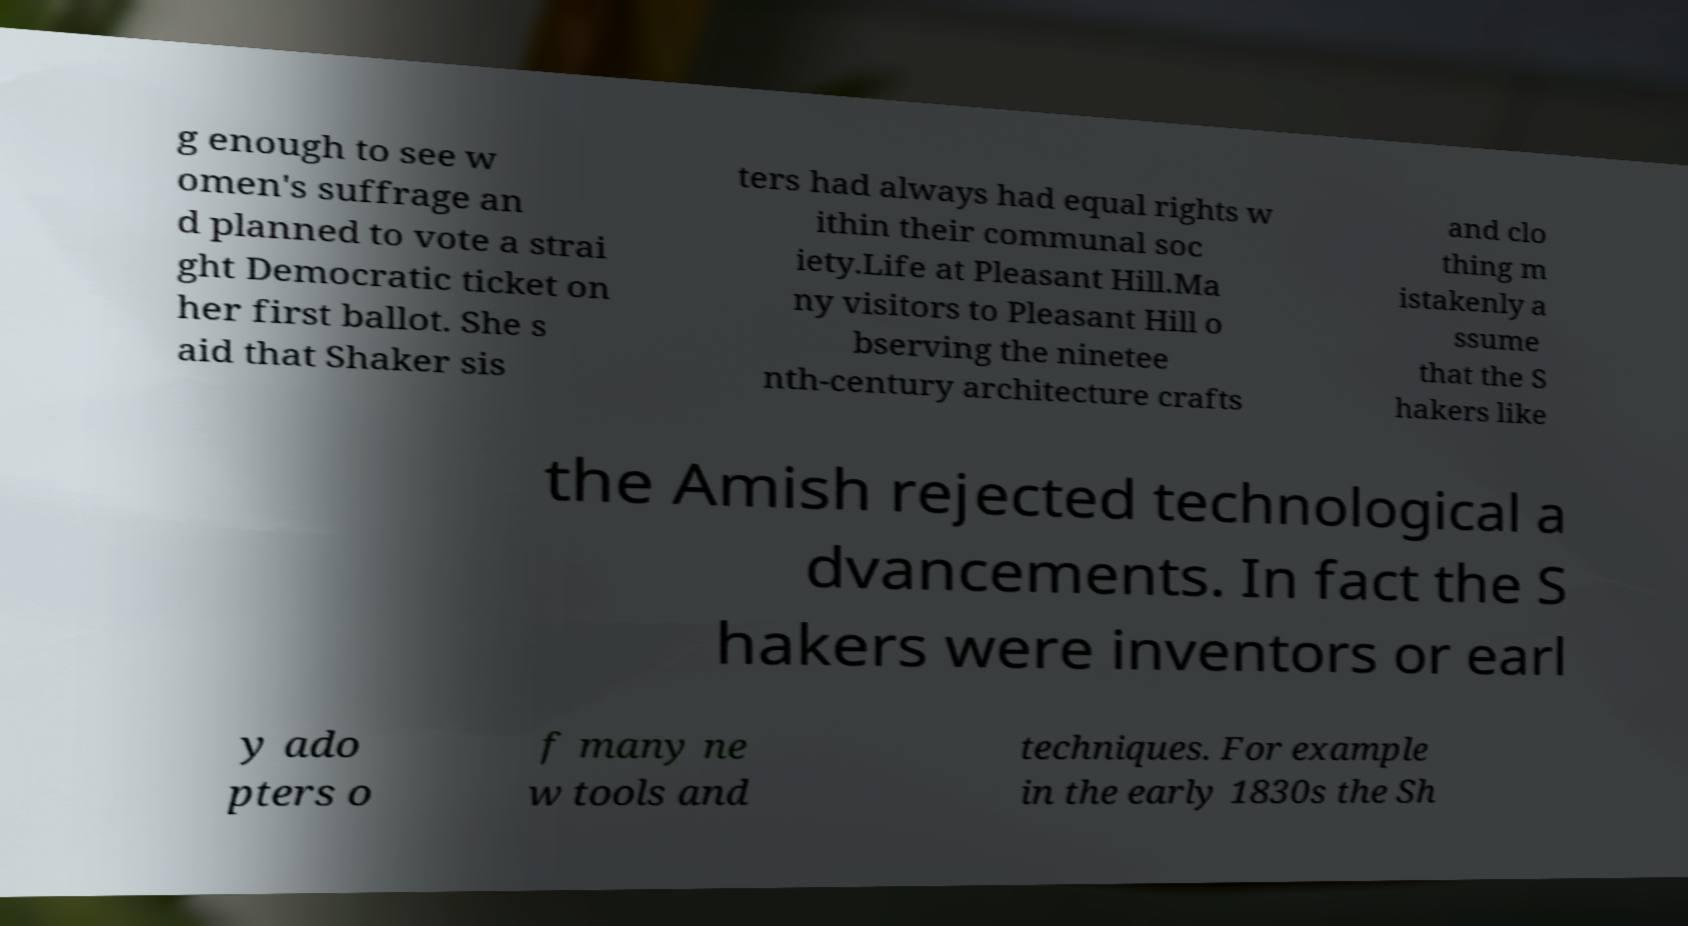There's text embedded in this image that I need extracted. Can you transcribe it verbatim? g enough to see w omen's suffrage an d planned to vote a strai ght Democratic ticket on her first ballot. She s aid that Shaker sis ters had always had equal rights w ithin their communal soc iety.Life at Pleasant Hill.Ma ny visitors to Pleasant Hill o bserving the ninetee nth-century architecture crafts and clo thing m istakenly a ssume that the S hakers like the Amish rejected technological a dvancements. In fact the S hakers were inventors or earl y ado pters o f many ne w tools and techniques. For example in the early 1830s the Sh 